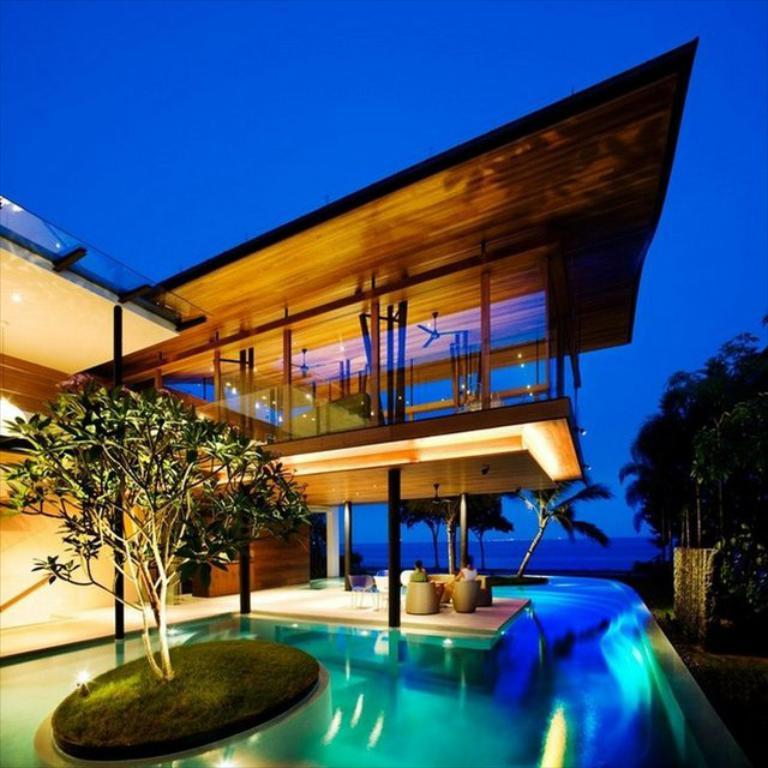What type of vegetation is on the left side of the image? There is a tree on the left side of the image. What can be seen at the bottom of the image? There is a swimming pool at the bottom of the image. What structure is located in the middle of the image? There is a house in the middle of the image. What is visible at the top of the image? The sky is visible at the top of the image. What type of regret can be seen on the tree in the image? There is no regret present in the image; it features a tree, a swimming pool, a house, and the sky. Is there a meeting happening in the image? There is no meeting depicted in the image. 